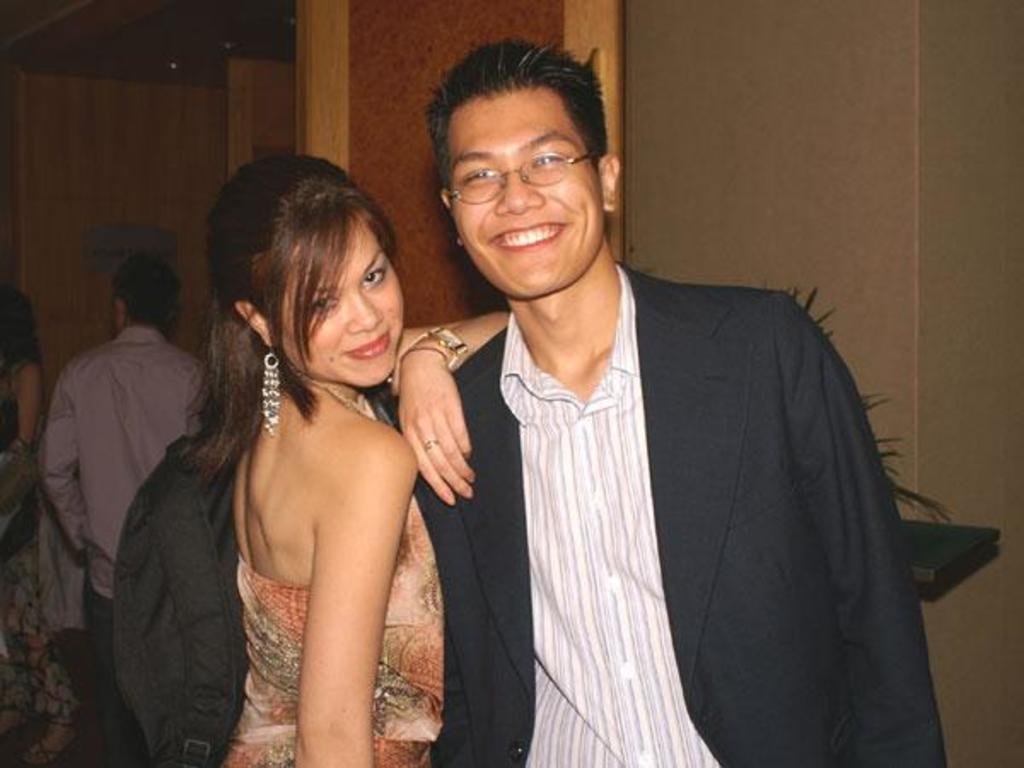What is the man in the image wearing? The man in the image is wearing a blazer. What accessory is the man wearing in the image? The man is wearing spectacles. Who else is present in the image? There is a woman in the image. What is the facial expression of the man and woman in the image? Both the man and woman are smiling. Can you describe the background of the image? There are people visible in the background of the image. What type of wire is being used to organize the shop in the image? There is no wire or shop present in the image; it features a man and a woman smiling. 